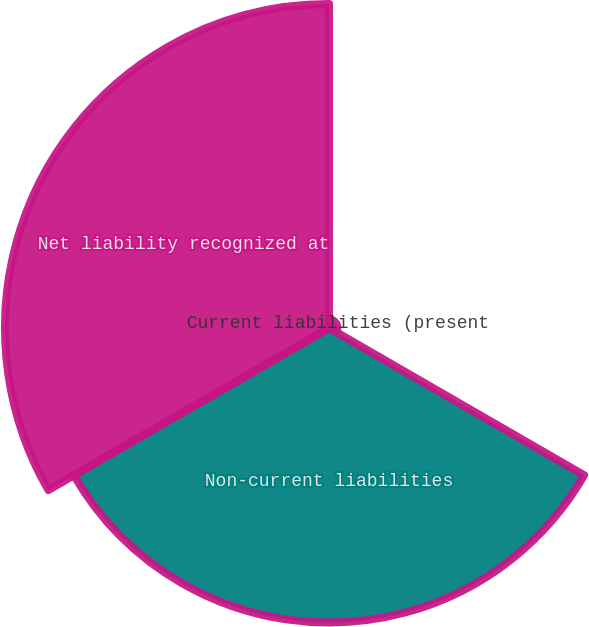Convert chart. <chart><loc_0><loc_0><loc_500><loc_500><pie_chart><fcel>Current liabilities (present<fcel>Non-current liabilities<fcel>Net liability recognized at<nl><fcel>1.35%<fcel>46.98%<fcel>51.68%<nl></chart> 